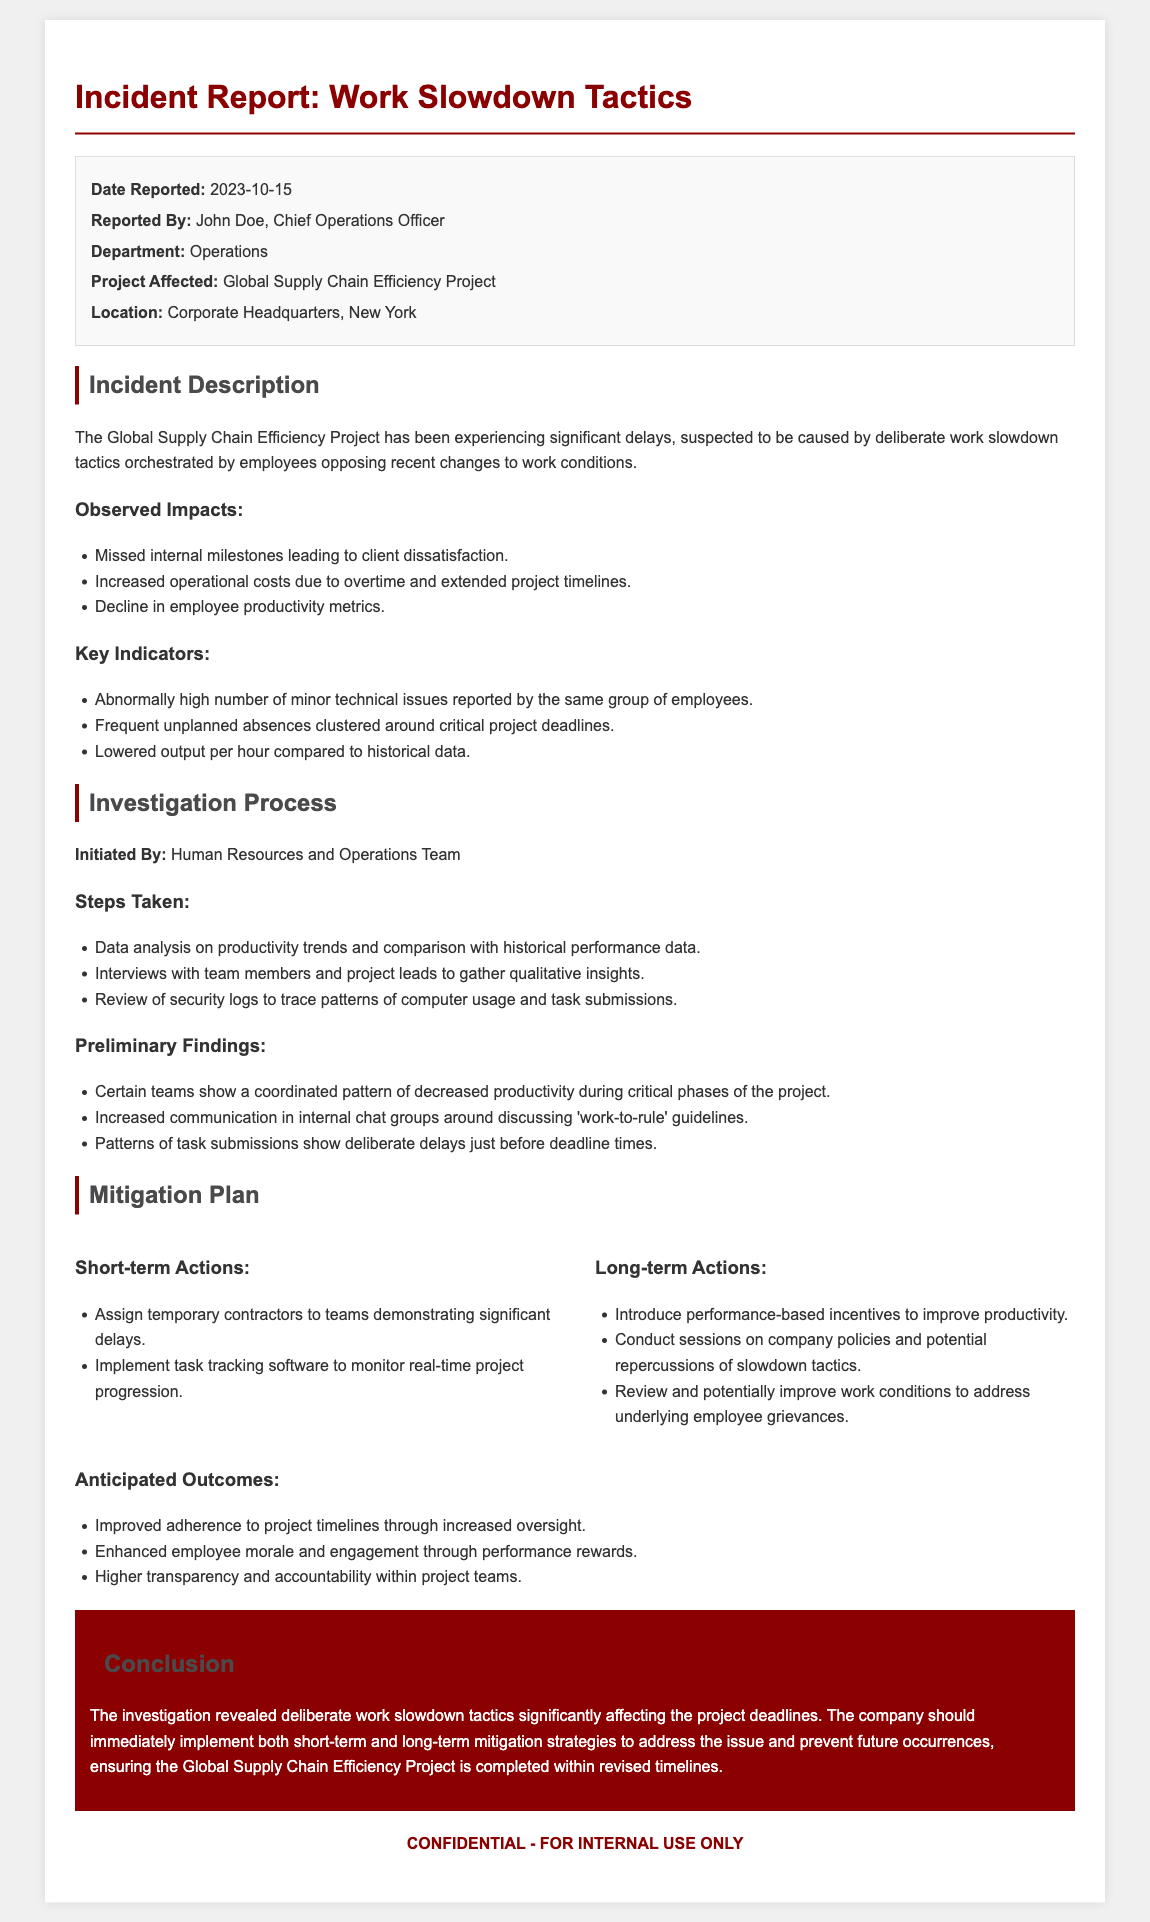What date was the incident reported? The date reported is explicitly mentioned in the document as October 15, 2023.
Answer: October 15, 2023 Who reported the incident? The individual who reported the incident is identified as John Doe in the document.
Answer: John Doe What project is affected by the work slowdown tactics? The document specifies that the affected project is the Global Supply Chain Efficiency Project.
Answer: Global Supply Chain Efficiency Project What are the key indicators of the slowdown? A list of key indicators is provided, including an abnormally high number of minor technical issues reported by a specific group of employees.
Answer: Abnormally high number of minor technical issues What is one short-term action suggested in the mitigation plan? The document outlines temporary contractors being assigned to teams demonstrating significant delays as a short-term action.
Answer: Assign temporary contractors What is the main anticipated outcome of the mitigation plan? The anticipated outcomes include improved adherence to project timelines as a primary goal stated in the document.
Answer: Improved adherence to project timelines What steps were taken during the investigation process? The investigation included data analysis on productivity trends, interviews with team members, and review of security logs.
Answer: Data analysis, interviews, review of security logs What is the conclusion of the report? The conclusion summarizes significant effects on project deadlines due to deliberate tactics and urges for immediate implementation of strategies.
Answer: Deliberate work slowdown tactics significantly affecting project deadlines 